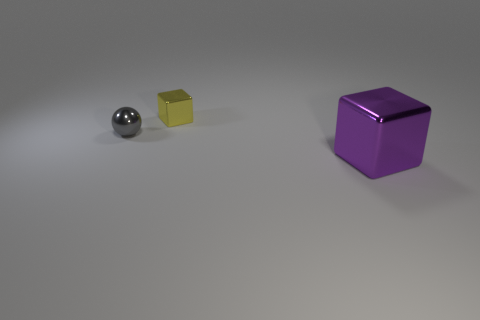What number of gray objects have the same size as the yellow object?
Keep it short and to the point. 1. What is the size of the yellow thing that is the same material as the gray ball?
Your answer should be very brief. Small. What number of other metal things have the same shape as the large purple metal thing?
Provide a short and direct response. 1. What number of big gray blocks are there?
Your answer should be very brief. 0. Does the tiny metallic object behind the gray shiny thing have the same shape as the gray object?
Make the answer very short. No. What material is the yellow cube that is the same size as the gray metal thing?
Ensure brevity in your answer.  Metal. Are there any objects that have the same material as the ball?
Make the answer very short. Yes. Is the shape of the tiny gray object the same as the small metal thing that is right of the gray metallic thing?
Keep it short and to the point. No. What number of shiny blocks are behind the small gray metal object and in front of the yellow object?
Ensure brevity in your answer.  0. Do the small gray object and the yellow thing that is behind the sphere have the same material?
Offer a terse response. Yes. 